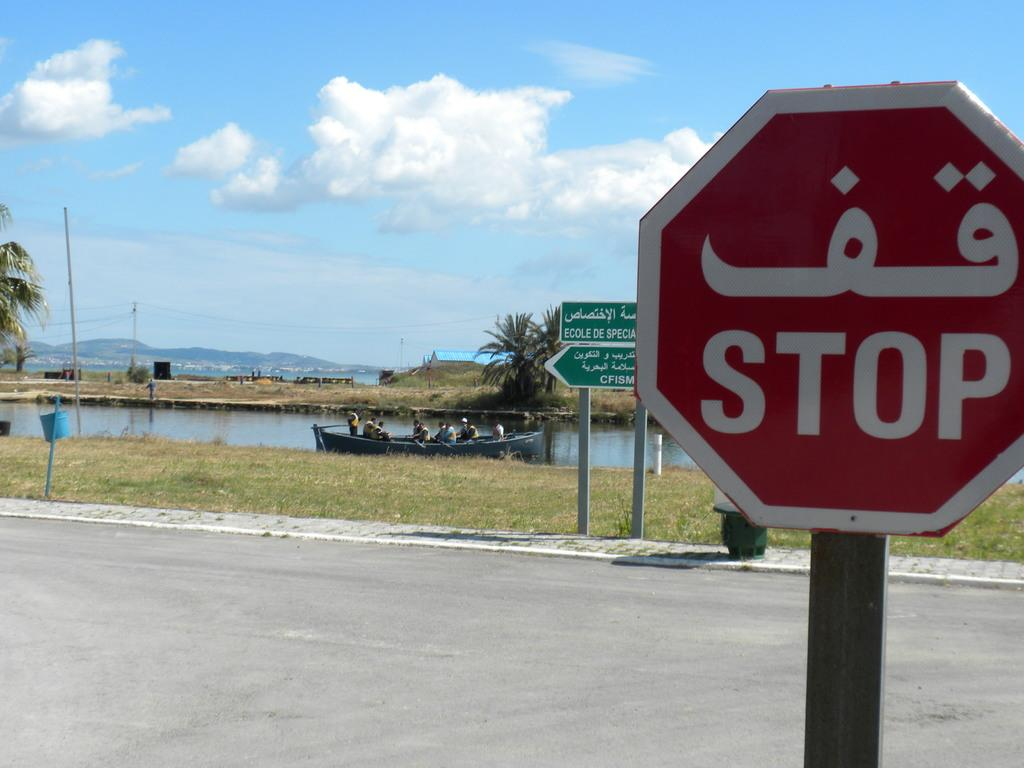<image>
Describe the image concisely. A stop sign in front of a river with a boat. 